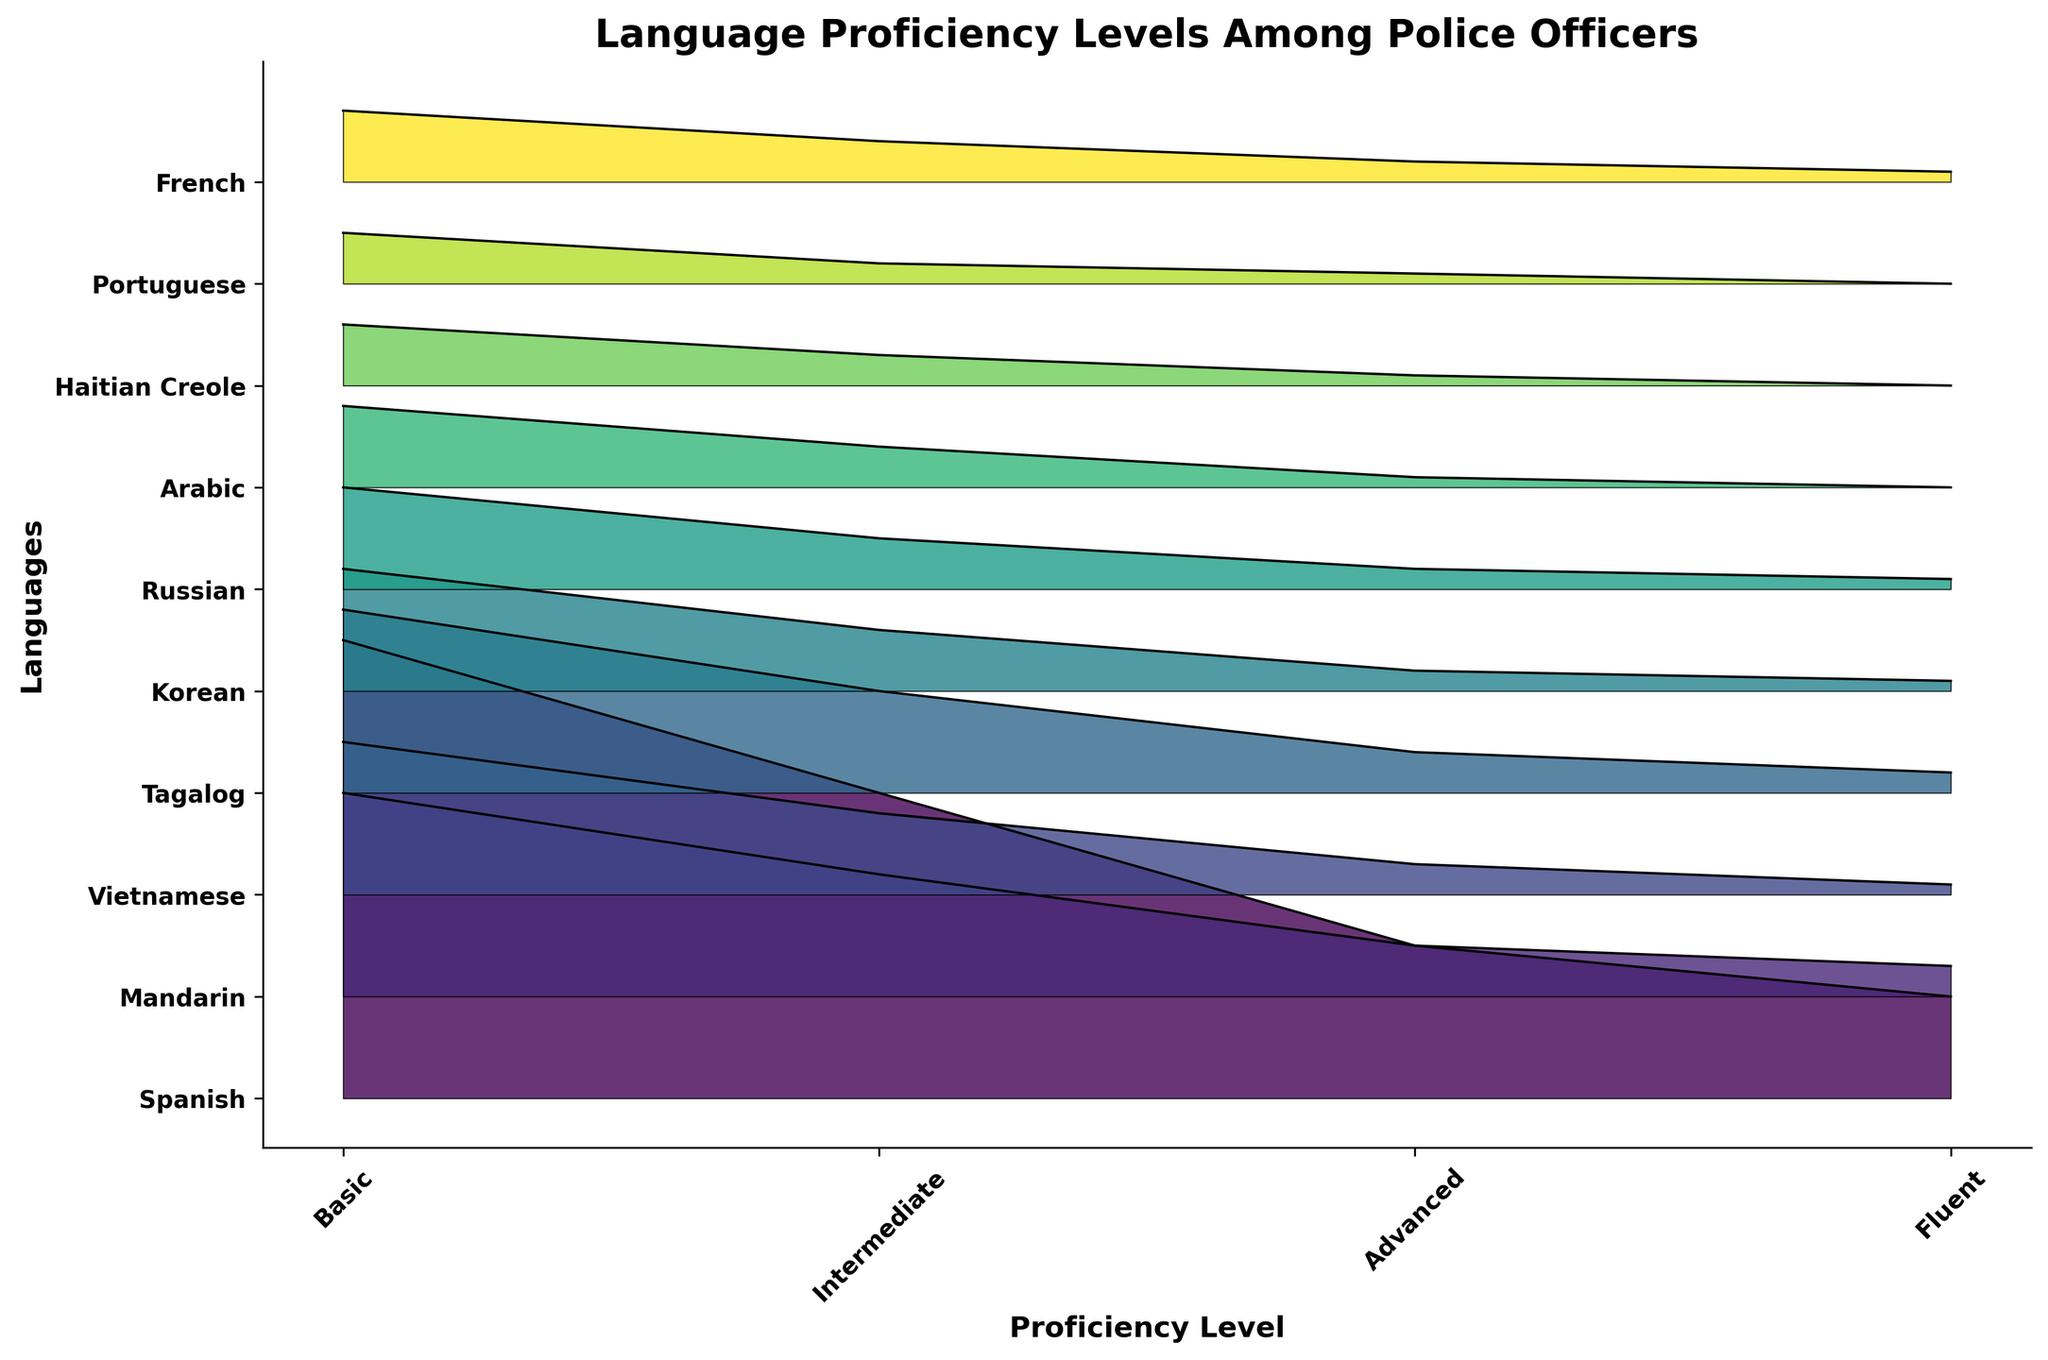Which language has the highest number of officers at the Basic proficiency level? Refer to the plot to see which language has the highest bar at the "Basic" level. Spanish has the highest bar at this level.
Answer: Spanish What is the total number of officers proficient in Mandarin and Vietnamese across all proficiency levels? Sum the values across all proficiency levels for both languages. Mandarin: 20 + 12 + 5 + 3 = 40, Vietnamese: 15 + 8 + 3 + 1 = 27, Total: 40 + 27 = 67
Answer: 67 Which languages have fewer than 2 officers at the Fluent level? Check the height of the bars at the "Fluent" level. Arabic, Haitian Creole, Portuguese have bars that do not reach the mark for 2.
Answer: Arabic, Haitian Creole, Portuguese How many more officers are there with Basic proficiency in Spanish than in Korean? Spanish has 45 officers at the Basic level, and Korean has 12. Subtract Korean's count from Spanish's count: 45 - 12 = 33
Answer: 33 Which languages have a higher number of officers at the Advanced level than at the Intermediate level? Compare the height of the bars between "Intermediate" and "Advanced" levels for each language. No language has a higher number at Advanced than at Intermediate upon inspection.
Answer: None What is the combined number of officers with Fluent proficiency in French and Russian? Add the values from the Fluent category for French and Russian. French: 1, Russian: 1, Total: 1 + 1 = 2
Answer: 2 Which language has the lowest number of officers with Basic proficiency, and how many are there? Check the height of the bars at the "Basic" proficiency level. Portuguese has the lowest with 5 officers.
Answer: Portuguese, 5 Compare the number of officers with Intermediate proficiency in Tagalog to those in Haitian Creole. Which is higher? Check the height of the "Intermediate" proficiency bars for Tagalog and Haitian Creole. Tagalog has 10, and Haitian Creole has 3, so Tagalog is higher.
Answer: Tagalog What's the difference in the number of officers with Intermediate proficiency between Spanish and Mandarin? Spanish has 30 officers and Mandarin has 12 officers at the Intermediate level. Subtract 12 from 30: 30 - 12 = 18
Answer: 18 